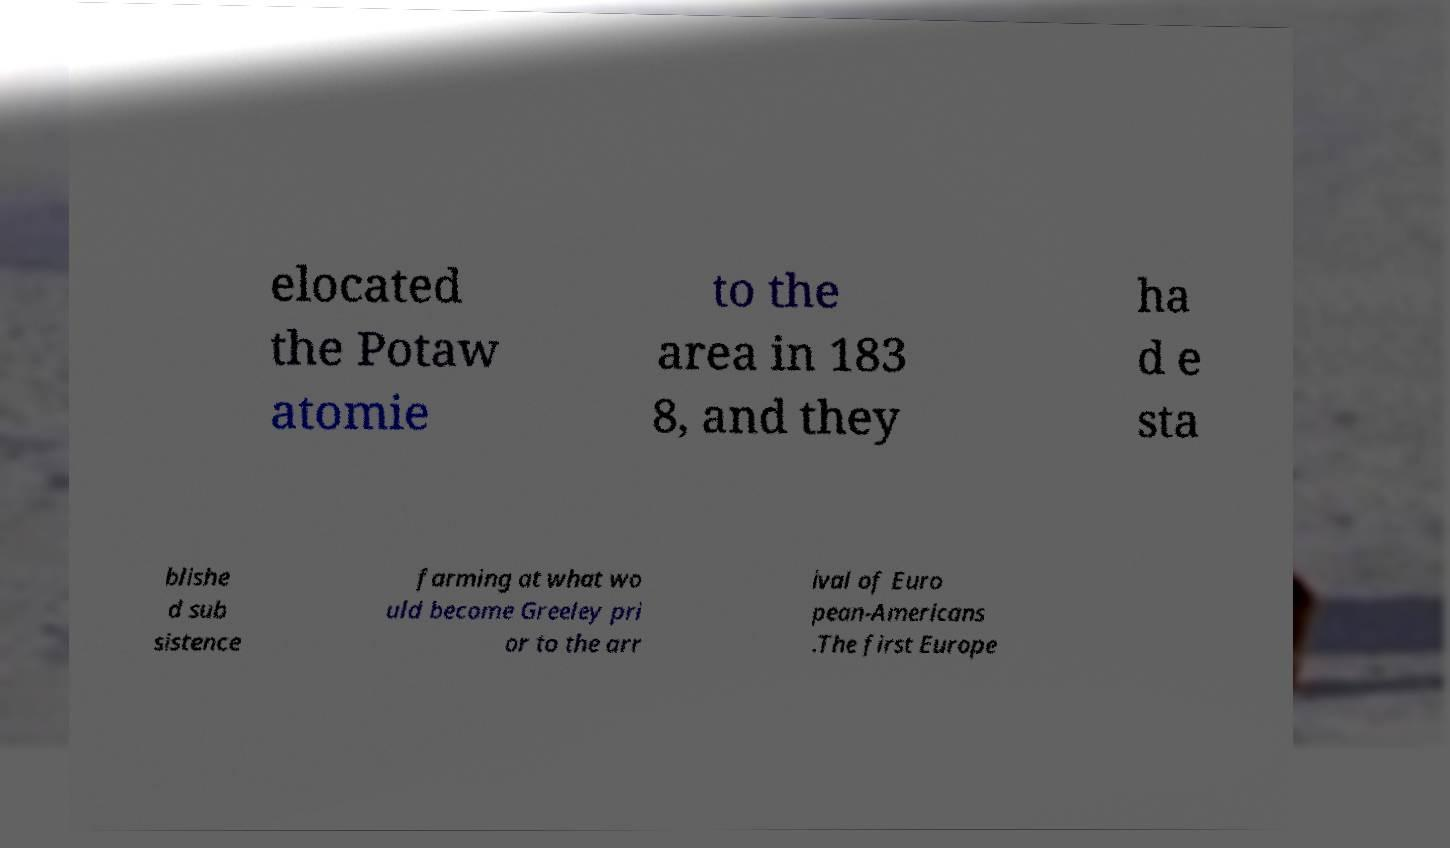There's text embedded in this image that I need extracted. Can you transcribe it verbatim? elocated the Potaw atomie to the area in 183 8, and they ha d e sta blishe d sub sistence farming at what wo uld become Greeley pri or to the arr ival of Euro pean-Americans .The first Europe 